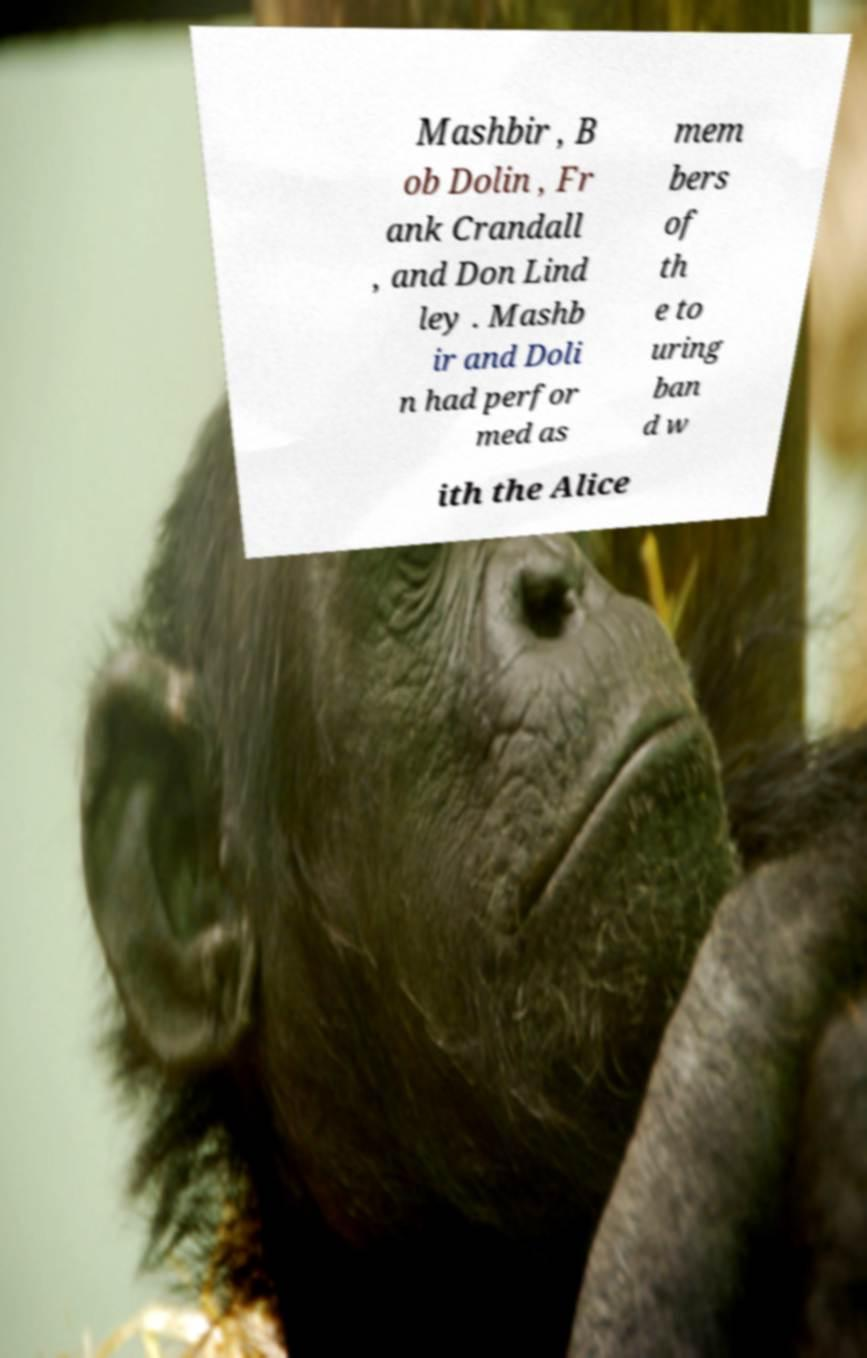Can you read and provide the text displayed in the image?This photo seems to have some interesting text. Can you extract and type it out for me? Mashbir , B ob Dolin , Fr ank Crandall , and Don Lind ley . Mashb ir and Doli n had perfor med as mem bers of th e to uring ban d w ith the Alice 